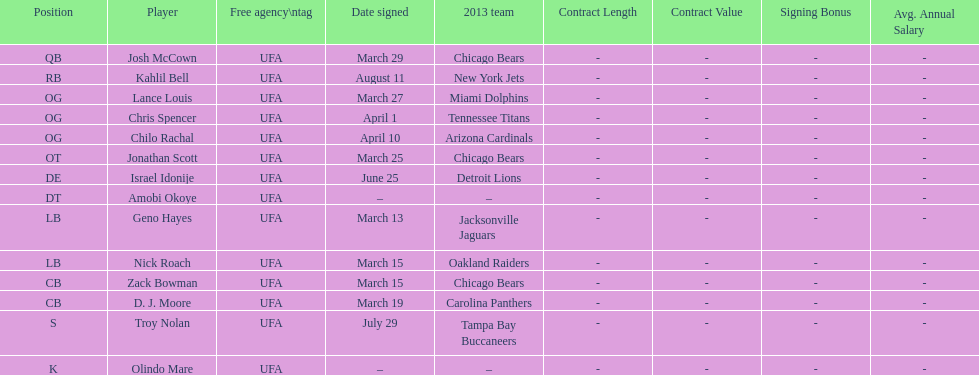His/her first name is the same name as a country. Israel Idonije. 